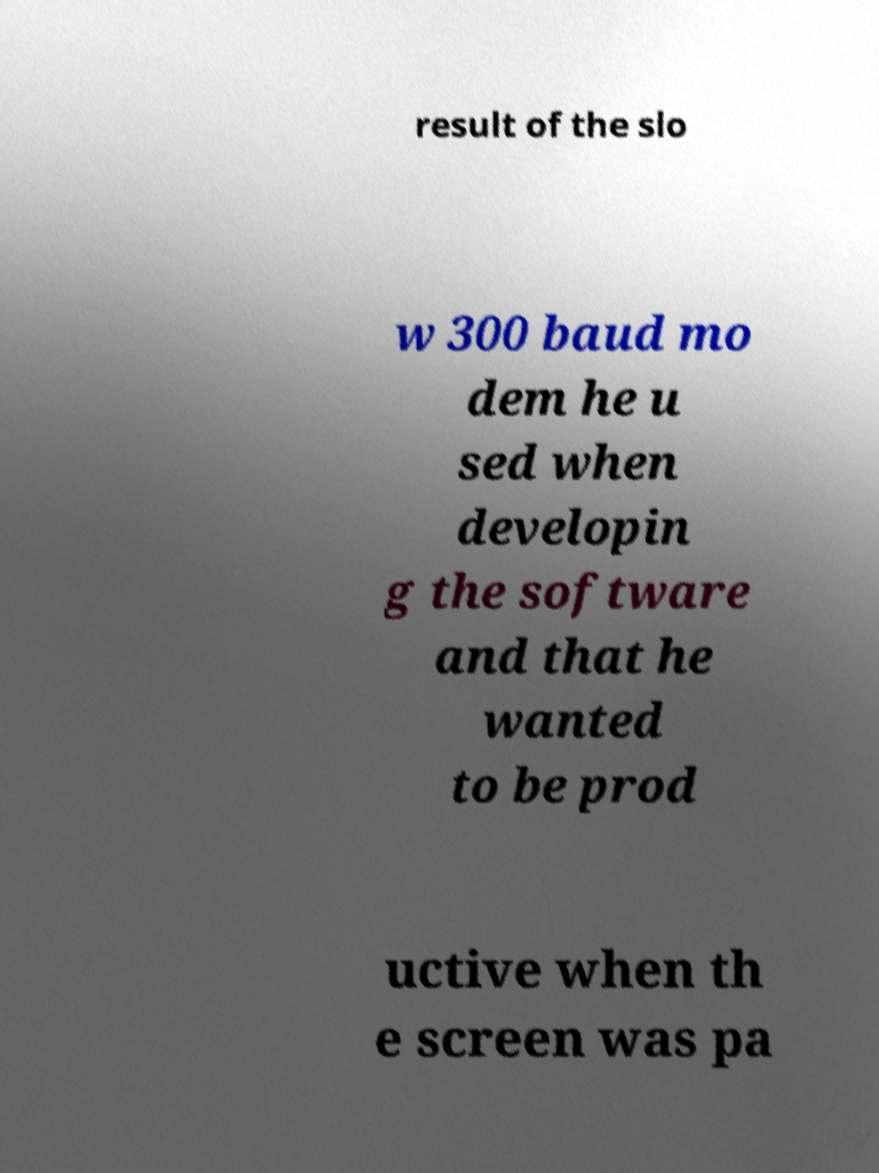Please identify and transcribe the text found in this image. result of the slo w 300 baud mo dem he u sed when developin g the software and that he wanted to be prod uctive when th e screen was pa 